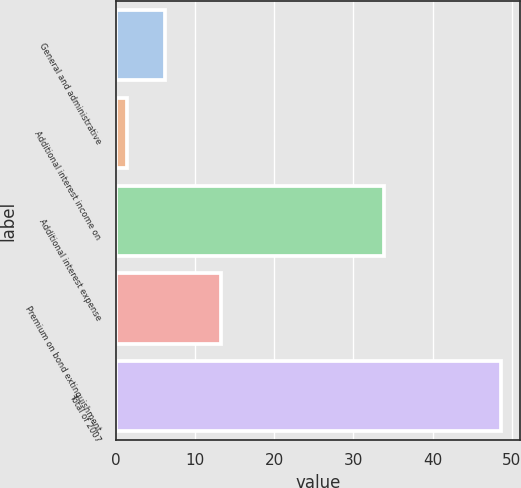<chart> <loc_0><loc_0><loc_500><loc_500><bar_chart><fcel>General and administrative<fcel>Additional interest income on<fcel>Additional interest expense<fcel>Premium on bond extinguishment<fcel>Total of 2007<nl><fcel>6.21<fcel>1.5<fcel>33.9<fcel>13.3<fcel>48.6<nl></chart> 